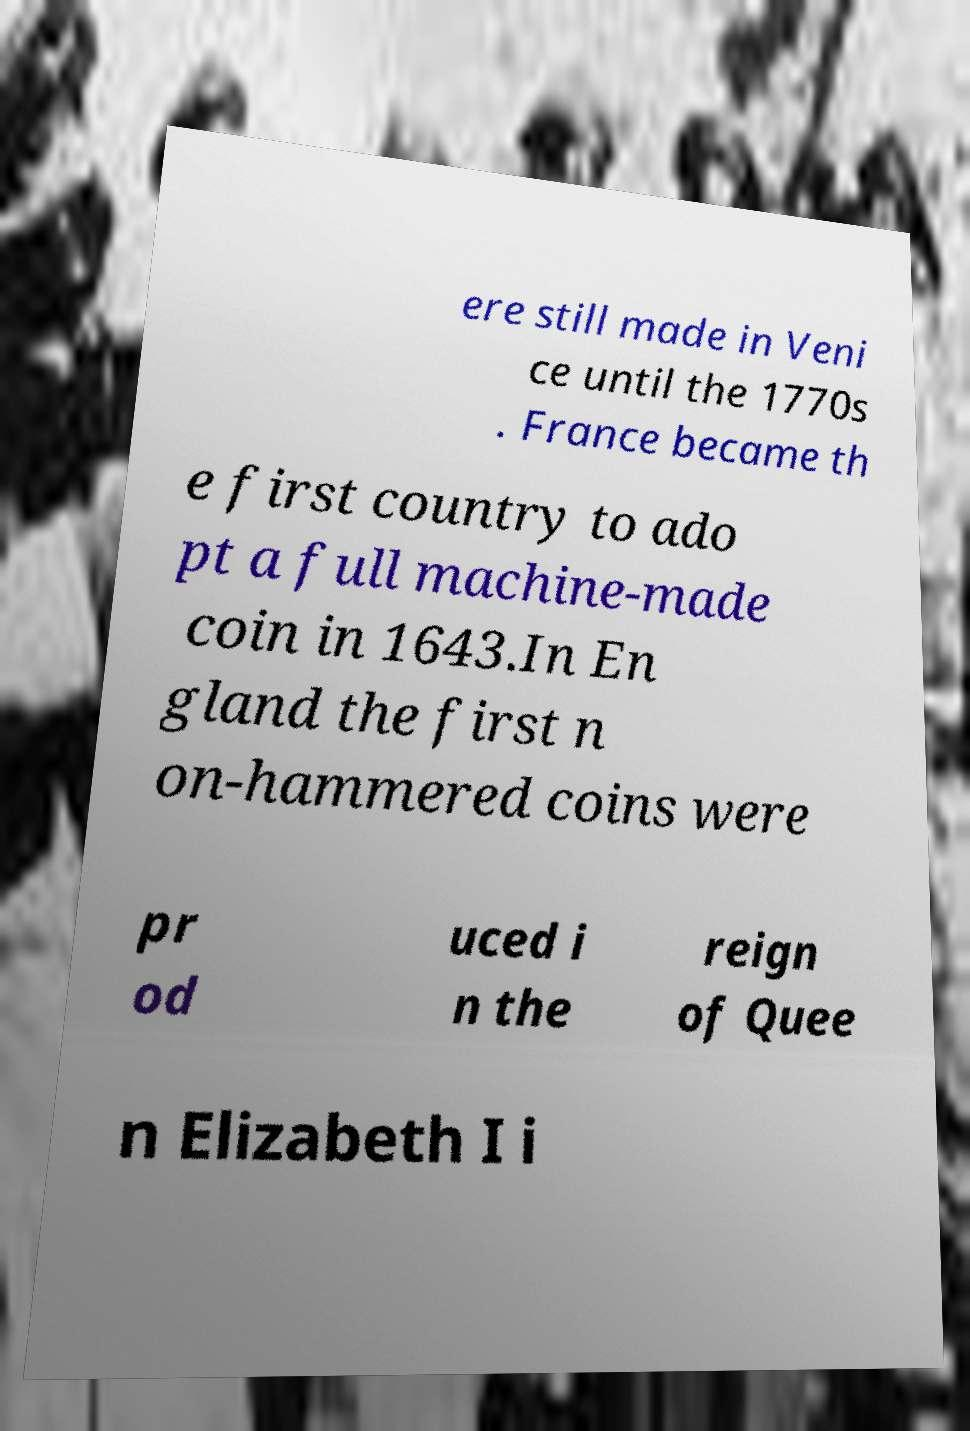What messages or text are displayed in this image? I need them in a readable, typed format. ere still made in Veni ce until the 1770s . France became th e first country to ado pt a full machine-made coin in 1643.In En gland the first n on-hammered coins were pr od uced i n the reign of Quee n Elizabeth I i 